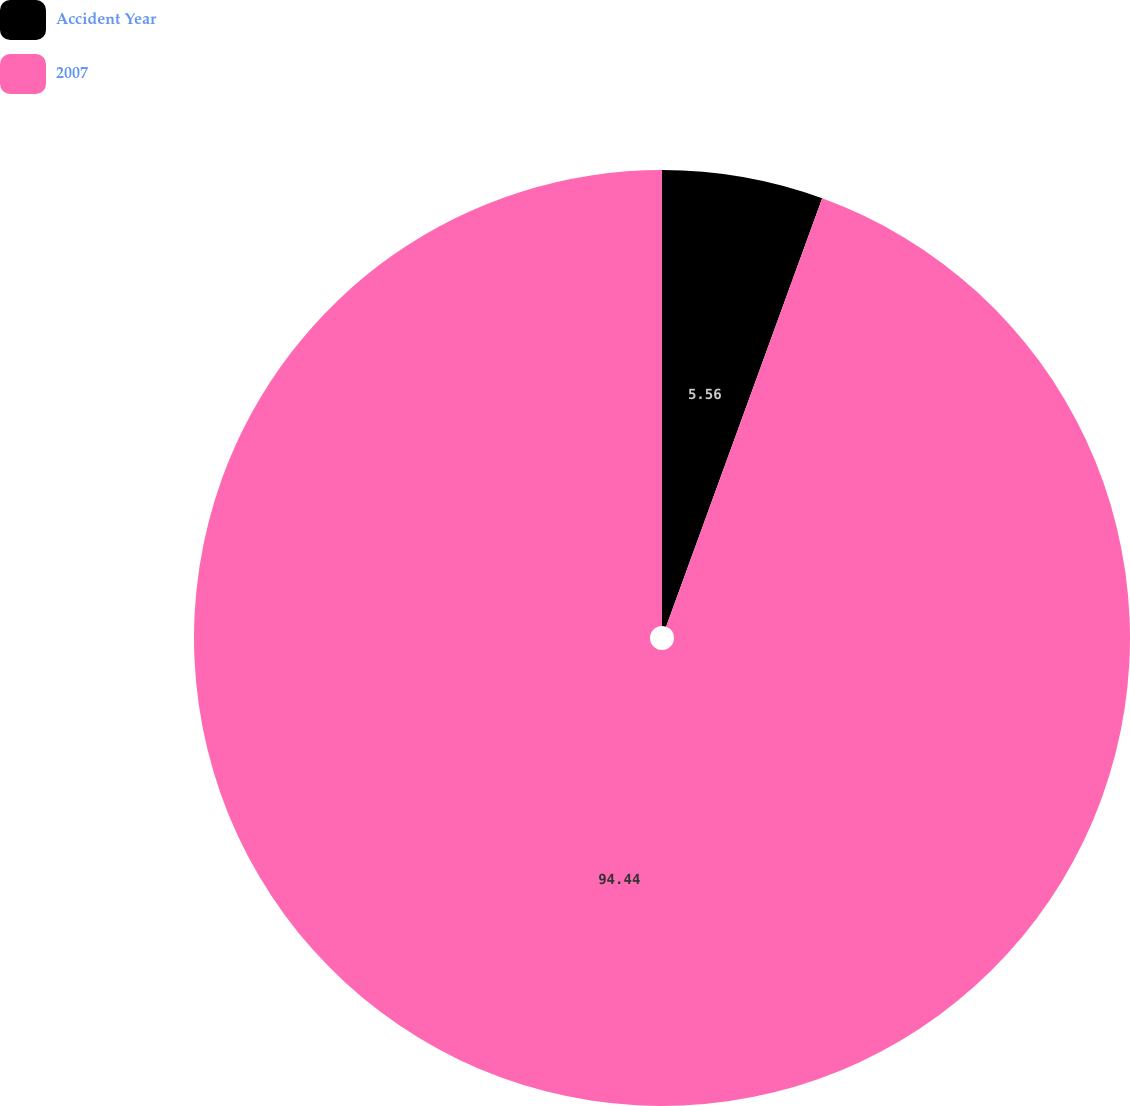Convert chart. <chart><loc_0><loc_0><loc_500><loc_500><pie_chart><fcel>Accident Year<fcel>2007<nl><fcel>5.56%<fcel>94.44%<nl></chart> 